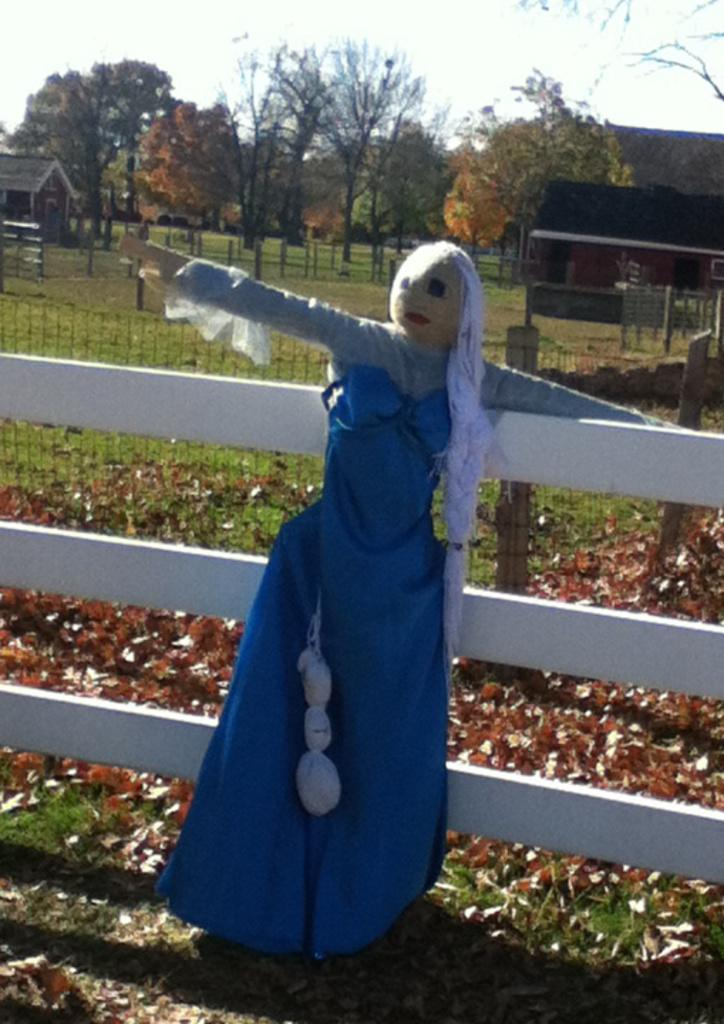What is located on the wooden fence in the image? There is a scarecrow on a wooden fence in the image. What can be seen in the background of the image? There are trees, plants, homes, and the sky visible in the background of the image. What type of coil is used to secure the library in the image? There is no library present in the image, so there is no coil used to secure it. 